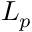Convert formula to latex. <formula><loc_0><loc_0><loc_500><loc_500>L _ { p }</formula> 